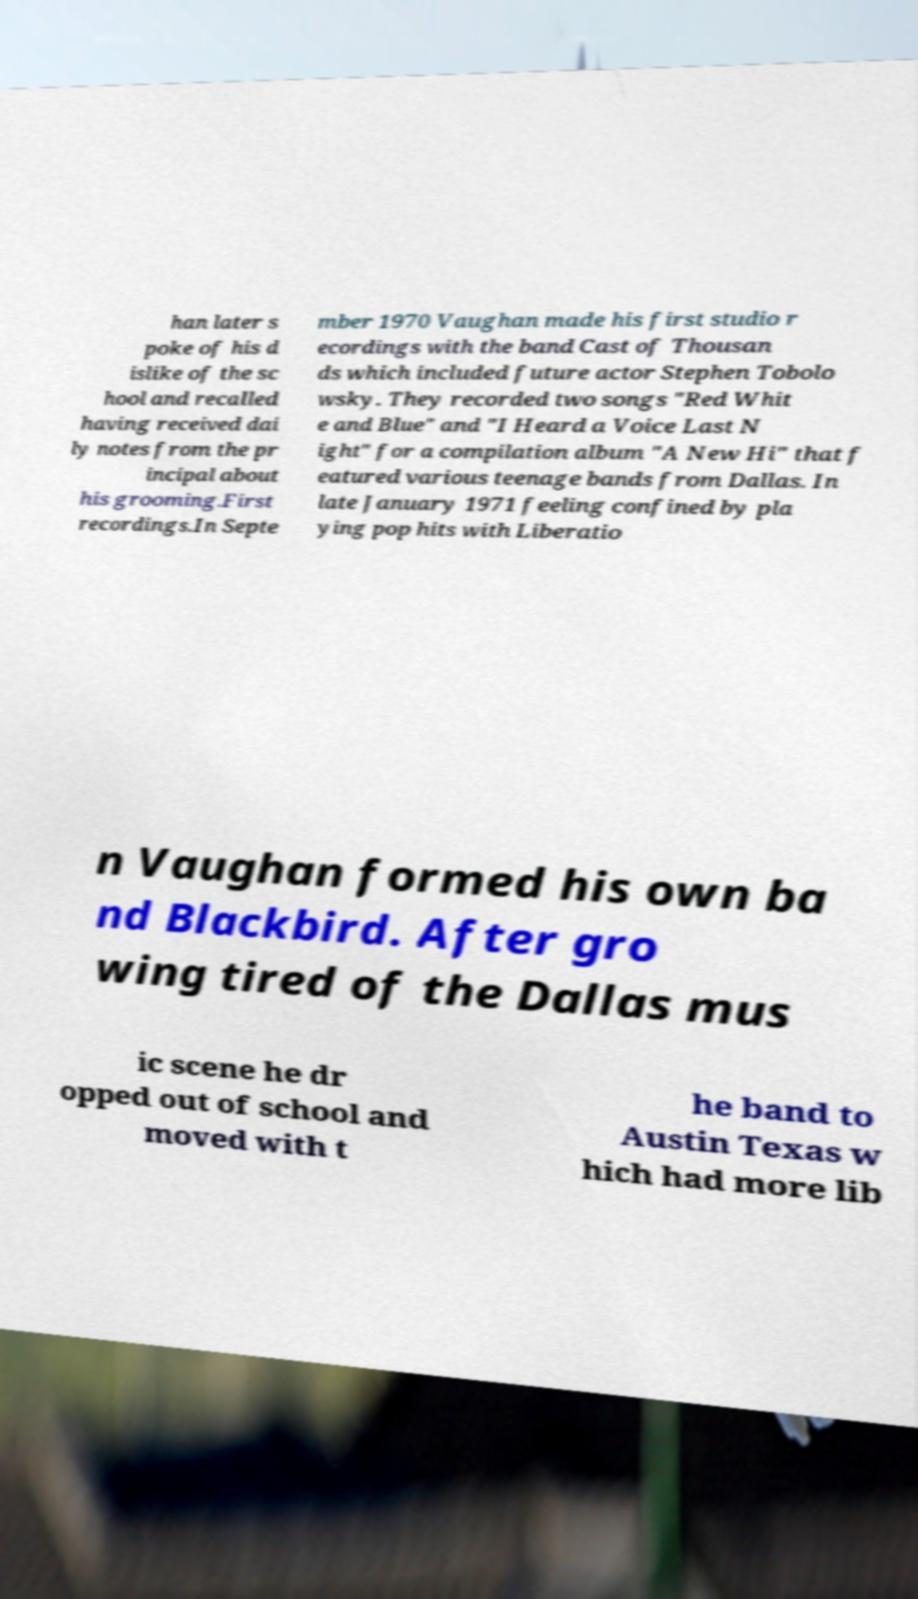I need the written content from this picture converted into text. Can you do that? han later s poke of his d islike of the sc hool and recalled having received dai ly notes from the pr incipal about his grooming.First recordings.In Septe mber 1970 Vaughan made his first studio r ecordings with the band Cast of Thousan ds which included future actor Stephen Tobolo wsky. They recorded two songs "Red Whit e and Blue" and "I Heard a Voice Last N ight" for a compilation album "A New Hi" that f eatured various teenage bands from Dallas. In late January 1971 feeling confined by pla ying pop hits with Liberatio n Vaughan formed his own ba nd Blackbird. After gro wing tired of the Dallas mus ic scene he dr opped out of school and moved with t he band to Austin Texas w hich had more lib 